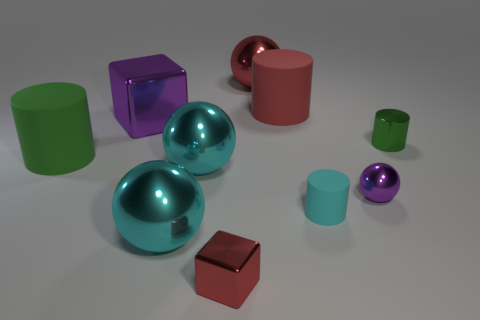What is the material of the red ball?
Offer a very short reply. Metal. What number of small cylinders are behind the small purple shiny sphere and to the left of the small green object?
Your answer should be very brief. 0. Do the metallic cylinder and the red matte cylinder have the same size?
Provide a succinct answer. No. Do the cube behind the cyan matte thing and the big green thing have the same size?
Provide a succinct answer. Yes. There is a rubber object behind the big green matte cylinder; what is its color?
Offer a terse response. Red. What number of small green rubber cylinders are there?
Make the answer very short. 0. There is a tiny cyan object that is the same material as the large green cylinder; what is its shape?
Provide a succinct answer. Cylinder. Does the large metal ball behind the big block have the same color as the large cylinder that is in front of the big purple thing?
Offer a terse response. No. Is the number of rubber things that are in front of the big green cylinder the same as the number of purple rubber cubes?
Your response must be concise. No. There is a purple shiny block; how many small objects are to the right of it?
Provide a short and direct response. 4. 